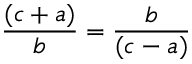Convert formula to latex. <formula><loc_0><loc_0><loc_500><loc_500>{ \frac { ( c + a ) } { b } } = { \frac { b } { ( c - a ) } }</formula> 